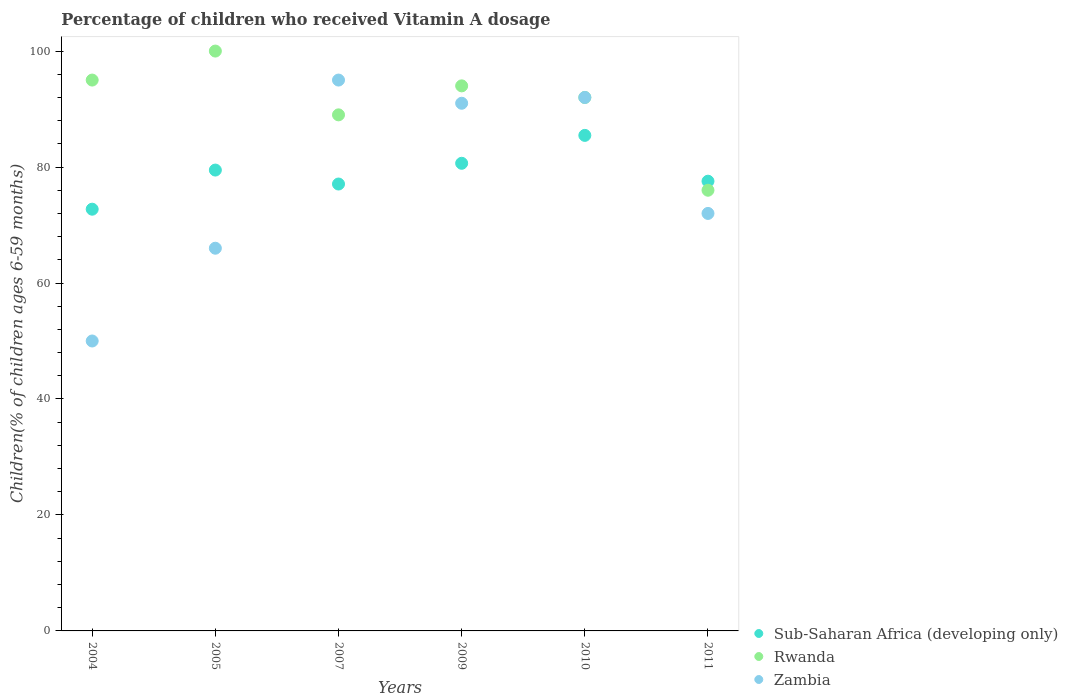Is the number of dotlines equal to the number of legend labels?
Provide a succinct answer. Yes. What is the percentage of children who received Vitamin A dosage in Sub-Saharan Africa (developing only) in 2005?
Your response must be concise. 79.48. Across all years, what is the maximum percentage of children who received Vitamin A dosage in Rwanda?
Keep it short and to the point. 100. What is the total percentage of children who received Vitamin A dosage in Sub-Saharan Africa (developing only) in the graph?
Your answer should be very brief. 472.95. What is the difference between the percentage of children who received Vitamin A dosage in Rwanda in 2009 and that in 2010?
Offer a terse response. 2. What is the difference between the percentage of children who received Vitamin A dosage in Zambia in 2011 and the percentage of children who received Vitamin A dosage in Rwanda in 2007?
Make the answer very short. -17. What is the average percentage of children who received Vitamin A dosage in Rwanda per year?
Your answer should be compact. 91. In the year 2011, what is the difference between the percentage of children who received Vitamin A dosage in Zambia and percentage of children who received Vitamin A dosage in Sub-Saharan Africa (developing only)?
Your answer should be compact. -5.56. In how many years, is the percentage of children who received Vitamin A dosage in Rwanda greater than 96 %?
Provide a short and direct response. 1. What is the ratio of the percentage of children who received Vitamin A dosage in Sub-Saharan Africa (developing only) in 2009 to that in 2011?
Ensure brevity in your answer.  1.04. Is the difference between the percentage of children who received Vitamin A dosage in Zambia in 2010 and 2011 greater than the difference between the percentage of children who received Vitamin A dosage in Sub-Saharan Africa (developing only) in 2010 and 2011?
Your response must be concise. Yes. What is the difference between the highest and the second highest percentage of children who received Vitamin A dosage in Sub-Saharan Africa (developing only)?
Keep it short and to the point. 4.81. What is the difference between the highest and the lowest percentage of children who received Vitamin A dosage in Zambia?
Offer a very short reply. 45. Is it the case that in every year, the sum of the percentage of children who received Vitamin A dosage in Zambia and percentage of children who received Vitamin A dosage in Rwanda  is greater than the percentage of children who received Vitamin A dosage in Sub-Saharan Africa (developing only)?
Offer a terse response. Yes. How many dotlines are there?
Make the answer very short. 3. What is the difference between two consecutive major ticks on the Y-axis?
Provide a succinct answer. 20. Does the graph contain any zero values?
Make the answer very short. No. Does the graph contain grids?
Your answer should be very brief. No. Where does the legend appear in the graph?
Your answer should be compact. Bottom right. What is the title of the graph?
Give a very brief answer. Percentage of children who received Vitamin A dosage. Does "Bangladesh" appear as one of the legend labels in the graph?
Make the answer very short. No. What is the label or title of the X-axis?
Your answer should be very brief. Years. What is the label or title of the Y-axis?
Offer a very short reply. Children(% of children ages 6-59 months). What is the Children(% of children ages 6-59 months) in Sub-Saharan Africa (developing only) in 2004?
Provide a short and direct response. 72.73. What is the Children(% of children ages 6-59 months) in Sub-Saharan Africa (developing only) in 2005?
Provide a succinct answer. 79.48. What is the Children(% of children ages 6-59 months) of Rwanda in 2005?
Your answer should be very brief. 100. What is the Children(% of children ages 6-59 months) of Zambia in 2005?
Provide a succinct answer. 66. What is the Children(% of children ages 6-59 months) of Sub-Saharan Africa (developing only) in 2007?
Your answer should be very brief. 77.07. What is the Children(% of children ages 6-59 months) in Rwanda in 2007?
Provide a short and direct response. 89. What is the Children(% of children ages 6-59 months) in Zambia in 2007?
Provide a short and direct response. 95. What is the Children(% of children ages 6-59 months) in Sub-Saharan Africa (developing only) in 2009?
Keep it short and to the point. 80.65. What is the Children(% of children ages 6-59 months) in Rwanda in 2009?
Your answer should be compact. 94. What is the Children(% of children ages 6-59 months) of Zambia in 2009?
Your answer should be very brief. 91. What is the Children(% of children ages 6-59 months) in Sub-Saharan Africa (developing only) in 2010?
Offer a very short reply. 85.46. What is the Children(% of children ages 6-59 months) in Rwanda in 2010?
Make the answer very short. 92. What is the Children(% of children ages 6-59 months) in Zambia in 2010?
Offer a terse response. 92. What is the Children(% of children ages 6-59 months) of Sub-Saharan Africa (developing only) in 2011?
Keep it short and to the point. 77.56. What is the Children(% of children ages 6-59 months) of Zambia in 2011?
Ensure brevity in your answer.  72. Across all years, what is the maximum Children(% of children ages 6-59 months) of Sub-Saharan Africa (developing only)?
Give a very brief answer. 85.46. Across all years, what is the maximum Children(% of children ages 6-59 months) of Zambia?
Offer a terse response. 95. Across all years, what is the minimum Children(% of children ages 6-59 months) in Sub-Saharan Africa (developing only)?
Give a very brief answer. 72.73. Across all years, what is the minimum Children(% of children ages 6-59 months) in Rwanda?
Your response must be concise. 76. Across all years, what is the minimum Children(% of children ages 6-59 months) of Zambia?
Keep it short and to the point. 50. What is the total Children(% of children ages 6-59 months) of Sub-Saharan Africa (developing only) in the graph?
Offer a terse response. 472.95. What is the total Children(% of children ages 6-59 months) in Rwanda in the graph?
Provide a succinct answer. 546. What is the total Children(% of children ages 6-59 months) of Zambia in the graph?
Your answer should be very brief. 466. What is the difference between the Children(% of children ages 6-59 months) in Sub-Saharan Africa (developing only) in 2004 and that in 2005?
Keep it short and to the point. -6.75. What is the difference between the Children(% of children ages 6-59 months) in Zambia in 2004 and that in 2005?
Ensure brevity in your answer.  -16. What is the difference between the Children(% of children ages 6-59 months) of Sub-Saharan Africa (developing only) in 2004 and that in 2007?
Your answer should be very brief. -4.34. What is the difference between the Children(% of children ages 6-59 months) of Zambia in 2004 and that in 2007?
Your answer should be very brief. -45. What is the difference between the Children(% of children ages 6-59 months) of Sub-Saharan Africa (developing only) in 2004 and that in 2009?
Offer a terse response. -7.92. What is the difference between the Children(% of children ages 6-59 months) of Rwanda in 2004 and that in 2009?
Provide a succinct answer. 1. What is the difference between the Children(% of children ages 6-59 months) of Zambia in 2004 and that in 2009?
Provide a succinct answer. -41. What is the difference between the Children(% of children ages 6-59 months) in Sub-Saharan Africa (developing only) in 2004 and that in 2010?
Your answer should be very brief. -12.73. What is the difference between the Children(% of children ages 6-59 months) of Rwanda in 2004 and that in 2010?
Keep it short and to the point. 3. What is the difference between the Children(% of children ages 6-59 months) of Zambia in 2004 and that in 2010?
Provide a succinct answer. -42. What is the difference between the Children(% of children ages 6-59 months) of Sub-Saharan Africa (developing only) in 2004 and that in 2011?
Offer a terse response. -4.83. What is the difference between the Children(% of children ages 6-59 months) of Rwanda in 2004 and that in 2011?
Your response must be concise. 19. What is the difference between the Children(% of children ages 6-59 months) in Zambia in 2004 and that in 2011?
Offer a very short reply. -22. What is the difference between the Children(% of children ages 6-59 months) of Sub-Saharan Africa (developing only) in 2005 and that in 2007?
Your answer should be compact. 2.41. What is the difference between the Children(% of children ages 6-59 months) of Sub-Saharan Africa (developing only) in 2005 and that in 2009?
Your answer should be very brief. -1.17. What is the difference between the Children(% of children ages 6-59 months) in Zambia in 2005 and that in 2009?
Provide a succinct answer. -25. What is the difference between the Children(% of children ages 6-59 months) of Sub-Saharan Africa (developing only) in 2005 and that in 2010?
Your response must be concise. -5.98. What is the difference between the Children(% of children ages 6-59 months) of Rwanda in 2005 and that in 2010?
Ensure brevity in your answer.  8. What is the difference between the Children(% of children ages 6-59 months) of Zambia in 2005 and that in 2010?
Your response must be concise. -26. What is the difference between the Children(% of children ages 6-59 months) in Sub-Saharan Africa (developing only) in 2005 and that in 2011?
Ensure brevity in your answer.  1.92. What is the difference between the Children(% of children ages 6-59 months) in Rwanda in 2005 and that in 2011?
Offer a terse response. 24. What is the difference between the Children(% of children ages 6-59 months) of Sub-Saharan Africa (developing only) in 2007 and that in 2009?
Provide a short and direct response. -3.58. What is the difference between the Children(% of children ages 6-59 months) in Rwanda in 2007 and that in 2009?
Provide a short and direct response. -5. What is the difference between the Children(% of children ages 6-59 months) in Zambia in 2007 and that in 2009?
Ensure brevity in your answer.  4. What is the difference between the Children(% of children ages 6-59 months) in Sub-Saharan Africa (developing only) in 2007 and that in 2010?
Your response must be concise. -8.39. What is the difference between the Children(% of children ages 6-59 months) in Rwanda in 2007 and that in 2010?
Your answer should be very brief. -3. What is the difference between the Children(% of children ages 6-59 months) of Sub-Saharan Africa (developing only) in 2007 and that in 2011?
Give a very brief answer. -0.49. What is the difference between the Children(% of children ages 6-59 months) in Zambia in 2007 and that in 2011?
Your response must be concise. 23. What is the difference between the Children(% of children ages 6-59 months) of Sub-Saharan Africa (developing only) in 2009 and that in 2010?
Provide a succinct answer. -4.81. What is the difference between the Children(% of children ages 6-59 months) of Sub-Saharan Africa (developing only) in 2009 and that in 2011?
Ensure brevity in your answer.  3.09. What is the difference between the Children(% of children ages 6-59 months) in Rwanda in 2009 and that in 2011?
Keep it short and to the point. 18. What is the difference between the Children(% of children ages 6-59 months) in Zambia in 2009 and that in 2011?
Your response must be concise. 19. What is the difference between the Children(% of children ages 6-59 months) in Sub-Saharan Africa (developing only) in 2010 and that in 2011?
Ensure brevity in your answer.  7.9. What is the difference between the Children(% of children ages 6-59 months) of Rwanda in 2010 and that in 2011?
Offer a very short reply. 16. What is the difference between the Children(% of children ages 6-59 months) in Sub-Saharan Africa (developing only) in 2004 and the Children(% of children ages 6-59 months) in Rwanda in 2005?
Keep it short and to the point. -27.27. What is the difference between the Children(% of children ages 6-59 months) in Sub-Saharan Africa (developing only) in 2004 and the Children(% of children ages 6-59 months) in Zambia in 2005?
Keep it short and to the point. 6.73. What is the difference between the Children(% of children ages 6-59 months) in Rwanda in 2004 and the Children(% of children ages 6-59 months) in Zambia in 2005?
Make the answer very short. 29. What is the difference between the Children(% of children ages 6-59 months) in Sub-Saharan Africa (developing only) in 2004 and the Children(% of children ages 6-59 months) in Rwanda in 2007?
Your answer should be compact. -16.27. What is the difference between the Children(% of children ages 6-59 months) of Sub-Saharan Africa (developing only) in 2004 and the Children(% of children ages 6-59 months) of Zambia in 2007?
Your response must be concise. -22.27. What is the difference between the Children(% of children ages 6-59 months) in Sub-Saharan Africa (developing only) in 2004 and the Children(% of children ages 6-59 months) in Rwanda in 2009?
Ensure brevity in your answer.  -21.27. What is the difference between the Children(% of children ages 6-59 months) in Sub-Saharan Africa (developing only) in 2004 and the Children(% of children ages 6-59 months) in Zambia in 2009?
Provide a succinct answer. -18.27. What is the difference between the Children(% of children ages 6-59 months) in Rwanda in 2004 and the Children(% of children ages 6-59 months) in Zambia in 2009?
Make the answer very short. 4. What is the difference between the Children(% of children ages 6-59 months) in Sub-Saharan Africa (developing only) in 2004 and the Children(% of children ages 6-59 months) in Rwanda in 2010?
Offer a very short reply. -19.27. What is the difference between the Children(% of children ages 6-59 months) in Sub-Saharan Africa (developing only) in 2004 and the Children(% of children ages 6-59 months) in Zambia in 2010?
Your answer should be compact. -19.27. What is the difference between the Children(% of children ages 6-59 months) of Rwanda in 2004 and the Children(% of children ages 6-59 months) of Zambia in 2010?
Your response must be concise. 3. What is the difference between the Children(% of children ages 6-59 months) of Sub-Saharan Africa (developing only) in 2004 and the Children(% of children ages 6-59 months) of Rwanda in 2011?
Offer a very short reply. -3.27. What is the difference between the Children(% of children ages 6-59 months) in Sub-Saharan Africa (developing only) in 2004 and the Children(% of children ages 6-59 months) in Zambia in 2011?
Give a very brief answer. 0.73. What is the difference between the Children(% of children ages 6-59 months) in Rwanda in 2004 and the Children(% of children ages 6-59 months) in Zambia in 2011?
Give a very brief answer. 23. What is the difference between the Children(% of children ages 6-59 months) in Sub-Saharan Africa (developing only) in 2005 and the Children(% of children ages 6-59 months) in Rwanda in 2007?
Provide a succinct answer. -9.52. What is the difference between the Children(% of children ages 6-59 months) of Sub-Saharan Africa (developing only) in 2005 and the Children(% of children ages 6-59 months) of Zambia in 2007?
Your response must be concise. -15.52. What is the difference between the Children(% of children ages 6-59 months) in Sub-Saharan Africa (developing only) in 2005 and the Children(% of children ages 6-59 months) in Rwanda in 2009?
Make the answer very short. -14.52. What is the difference between the Children(% of children ages 6-59 months) of Sub-Saharan Africa (developing only) in 2005 and the Children(% of children ages 6-59 months) of Zambia in 2009?
Offer a very short reply. -11.52. What is the difference between the Children(% of children ages 6-59 months) in Rwanda in 2005 and the Children(% of children ages 6-59 months) in Zambia in 2009?
Ensure brevity in your answer.  9. What is the difference between the Children(% of children ages 6-59 months) of Sub-Saharan Africa (developing only) in 2005 and the Children(% of children ages 6-59 months) of Rwanda in 2010?
Give a very brief answer. -12.52. What is the difference between the Children(% of children ages 6-59 months) in Sub-Saharan Africa (developing only) in 2005 and the Children(% of children ages 6-59 months) in Zambia in 2010?
Give a very brief answer. -12.52. What is the difference between the Children(% of children ages 6-59 months) of Sub-Saharan Africa (developing only) in 2005 and the Children(% of children ages 6-59 months) of Rwanda in 2011?
Offer a terse response. 3.48. What is the difference between the Children(% of children ages 6-59 months) of Sub-Saharan Africa (developing only) in 2005 and the Children(% of children ages 6-59 months) of Zambia in 2011?
Keep it short and to the point. 7.48. What is the difference between the Children(% of children ages 6-59 months) in Rwanda in 2005 and the Children(% of children ages 6-59 months) in Zambia in 2011?
Your answer should be very brief. 28. What is the difference between the Children(% of children ages 6-59 months) of Sub-Saharan Africa (developing only) in 2007 and the Children(% of children ages 6-59 months) of Rwanda in 2009?
Offer a terse response. -16.93. What is the difference between the Children(% of children ages 6-59 months) in Sub-Saharan Africa (developing only) in 2007 and the Children(% of children ages 6-59 months) in Zambia in 2009?
Offer a terse response. -13.93. What is the difference between the Children(% of children ages 6-59 months) of Sub-Saharan Africa (developing only) in 2007 and the Children(% of children ages 6-59 months) of Rwanda in 2010?
Provide a short and direct response. -14.93. What is the difference between the Children(% of children ages 6-59 months) in Sub-Saharan Africa (developing only) in 2007 and the Children(% of children ages 6-59 months) in Zambia in 2010?
Your answer should be very brief. -14.93. What is the difference between the Children(% of children ages 6-59 months) of Sub-Saharan Africa (developing only) in 2007 and the Children(% of children ages 6-59 months) of Rwanda in 2011?
Provide a short and direct response. 1.07. What is the difference between the Children(% of children ages 6-59 months) of Sub-Saharan Africa (developing only) in 2007 and the Children(% of children ages 6-59 months) of Zambia in 2011?
Provide a succinct answer. 5.07. What is the difference between the Children(% of children ages 6-59 months) in Sub-Saharan Africa (developing only) in 2009 and the Children(% of children ages 6-59 months) in Rwanda in 2010?
Give a very brief answer. -11.35. What is the difference between the Children(% of children ages 6-59 months) of Sub-Saharan Africa (developing only) in 2009 and the Children(% of children ages 6-59 months) of Zambia in 2010?
Your response must be concise. -11.35. What is the difference between the Children(% of children ages 6-59 months) in Rwanda in 2009 and the Children(% of children ages 6-59 months) in Zambia in 2010?
Ensure brevity in your answer.  2. What is the difference between the Children(% of children ages 6-59 months) in Sub-Saharan Africa (developing only) in 2009 and the Children(% of children ages 6-59 months) in Rwanda in 2011?
Give a very brief answer. 4.65. What is the difference between the Children(% of children ages 6-59 months) in Sub-Saharan Africa (developing only) in 2009 and the Children(% of children ages 6-59 months) in Zambia in 2011?
Offer a very short reply. 8.65. What is the difference between the Children(% of children ages 6-59 months) of Sub-Saharan Africa (developing only) in 2010 and the Children(% of children ages 6-59 months) of Rwanda in 2011?
Provide a succinct answer. 9.46. What is the difference between the Children(% of children ages 6-59 months) in Sub-Saharan Africa (developing only) in 2010 and the Children(% of children ages 6-59 months) in Zambia in 2011?
Provide a short and direct response. 13.46. What is the average Children(% of children ages 6-59 months) of Sub-Saharan Africa (developing only) per year?
Keep it short and to the point. 78.82. What is the average Children(% of children ages 6-59 months) of Rwanda per year?
Your answer should be very brief. 91. What is the average Children(% of children ages 6-59 months) of Zambia per year?
Provide a short and direct response. 77.67. In the year 2004, what is the difference between the Children(% of children ages 6-59 months) in Sub-Saharan Africa (developing only) and Children(% of children ages 6-59 months) in Rwanda?
Your answer should be very brief. -22.27. In the year 2004, what is the difference between the Children(% of children ages 6-59 months) of Sub-Saharan Africa (developing only) and Children(% of children ages 6-59 months) of Zambia?
Your answer should be very brief. 22.73. In the year 2004, what is the difference between the Children(% of children ages 6-59 months) of Rwanda and Children(% of children ages 6-59 months) of Zambia?
Offer a terse response. 45. In the year 2005, what is the difference between the Children(% of children ages 6-59 months) in Sub-Saharan Africa (developing only) and Children(% of children ages 6-59 months) in Rwanda?
Your answer should be compact. -20.52. In the year 2005, what is the difference between the Children(% of children ages 6-59 months) of Sub-Saharan Africa (developing only) and Children(% of children ages 6-59 months) of Zambia?
Provide a succinct answer. 13.48. In the year 2005, what is the difference between the Children(% of children ages 6-59 months) in Rwanda and Children(% of children ages 6-59 months) in Zambia?
Provide a succinct answer. 34. In the year 2007, what is the difference between the Children(% of children ages 6-59 months) of Sub-Saharan Africa (developing only) and Children(% of children ages 6-59 months) of Rwanda?
Your answer should be compact. -11.93. In the year 2007, what is the difference between the Children(% of children ages 6-59 months) of Sub-Saharan Africa (developing only) and Children(% of children ages 6-59 months) of Zambia?
Make the answer very short. -17.93. In the year 2007, what is the difference between the Children(% of children ages 6-59 months) in Rwanda and Children(% of children ages 6-59 months) in Zambia?
Offer a terse response. -6. In the year 2009, what is the difference between the Children(% of children ages 6-59 months) in Sub-Saharan Africa (developing only) and Children(% of children ages 6-59 months) in Rwanda?
Offer a terse response. -13.35. In the year 2009, what is the difference between the Children(% of children ages 6-59 months) of Sub-Saharan Africa (developing only) and Children(% of children ages 6-59 months) of Zambia?
Provide a short and direct response. -10.35. In the year 2010, what is the difference between the Children(% of children ages 6-59 months) in Sub-Saharan Africa (developing only) and Children(% of children ages 6-59 months) in Rwanda?
Offer a very short reply. -6.54. In the year 2010, what is the difference between the Children(% of children ages 6-59 months) of Sub-Saharan Africa (developing only) and Children(% of children ages 6-59 months) of Zambia?
Keep it short and to the point. -6.54. In the year 2011, what is the difference between the Children(% of children ages 6-59 months) of Sub-Saharan Africa (developing only) and Children(% of children ages 6-59 months) of Rwanda?
Ensure brevity in your answer.  1.56. In the year 2011, what is the difference between the Children(% of children ages 6-59 months) in Sub-Saharan Africa (developing only) and Children(% of children ages 6-59 months) in Zambia?
Give a very brief answer. 5.56. In the year 2011, what is the difference between the Children(% of children ages 6-59 months) in Rwanda and Children(% of children ages 6-59 months) in Zambia?
Make the answer very short. 4. What is the ratio of the Children(% of children ages 6-59 months) of Sub-Saharan Africa (developing only) in 2004 to that in 2005?
Offer a terse response. 0.92. What is the ratio of the Children(% of children ages 6-59 months) in Zambia in 2004 to that in 2005?
Offer a very short reply. 0.76. What is the ratio of the Children(% of children ages 6-59 months) in Sub-Saharan Africa (developing only) in 2004 to that in 2007?
Ensure brevity in your answer.  0.94. What is the ratio of the Children(% of children ages 6-59 months) in Rwanda in 2004 to that in 2007?
Keep it short and to the point. 1.07. What is the ratio of the Children(% of children ages 6-59 months) of Zambia in 2004 to that in 2007?
Provide a short and direct response. 0.53. What is the ratio of the Children(% of children ages 6-59 months) in Sub-Saharan Africa (developing only) in 2004 to that in 2009?
Provide a succinct answer. 0.9. What is the ratio of the Children(% of children ages 6-59 months) of Rwanda in 2004 to that in 2009?
Provide a short and direct response. 1.01. What is the ratio of the Children(% of children ages 6-59 months) of Zambia in 2004 to that in 2009?
Offer a very short reply. 0.55. What is the ratio of the Children(% of children ages 6-59 months) in Sub-Saharan Africa (developing only) in 2004 to that in 2010?
Ensure brevity in your answer.  0.85. What is the ratio of the Children(% of children ages 6-59 months) of Rwanda in 2004 to that in 2010?
Make the answer very short. 1.03. What is the ratio of the Children(% of children ages 6-59 months) of Zambia in 2004 to that in 2010?
Provide a short and direct response. 0.54. What is the ratio of the Children(% of children ages 6-59 months) of Sub-Saharan Africa (developing only) in 2004 to that in 2011?
Keep it short and to the point. 0.94. What is the ratio of the Children(% of children ages 6-59 months) of Zambia in 2004 to that in 2011?
Make the answer very short. 0.69. What is the ratio of the Children(% of children ages 6-59 months) of Sub-Saharan Africa (developing only) in 2005 to that in 2007?
Your answer should be compact. 1.03. What is the ratio of the Children(% of children ages 6-59 months) in Rwanda in 2005 to that in 2007?
Your response must be concise. 1.12. What is the ratio of the Children(% of children ages 6-59 months) of Zambia in 2005 to that in 2007?
Give a very brief answer. 0.69. What is the ratio of the Children(% of children ages 6-59 months) in Sub-Saharan Africa (developing only) in 2005 to that in 2009?
Your answer should be compact. 0.99. What is the ratio of the Children(% of children ages 6-59 months) of Rwanda in 2005 to that in 2009?
Offer a very short reply. 1.06. What is the ratio of the Children(% of children ages 6-59 months) of Zambia in 2005 to that in 2009?
Provide a short and direct response. 0.73. What is the ratio of the Children(% of children ages 6-59 months) of Sub-Saharan Africa (developing only) in 2005 to that in 2010?
Your response must be concise. 0.93. What is the ratio of the Children(% of children ages 6-59 months) in Rwanda in 2005 to that in 2010?
Offer a terse response. 1.09. What is the ratio of the Children(% of children ages 6-59 months) of Zambia in 2005 to that in 2010?
Your answer should be very brief. 0.72. What is the ratio of the Children(% of children ages 6-59 months) in Sub-Saharan Africa (developing only) in 2005 to that in 2011?
Offer a terse response. 1.02. What is the ratio of the Children(% of children ages 6-59 months) of Rwanda in 2005 to that in 2011?
Your answer should be compact. 1.32. What is the ratio of the Children(% of children ages 6-59 months) in Zambia in 2005 to that in 2011?
Make the answer very short. 0.92. What is the ratio of the Children(% of children ages 6-59 months) of Sub-Saharan Africa (developing only) in 2007 to that in 2009?
Offer a very short reply. 0.96. What is the ratio of the Children(% of children ages 6-59 months) of Rwanda in 2007 to that in 2009?
Provide a short and direct response. 0.95. What is the ratio of the Children(% of children ages 6-59 months) in Zambia in 2007 to that in 2009?
Give a very brief answer. 1.04. What is the ratio of the Children(% of children ages 6-59 months) of Sub-Saharan Africa (developing only) in 2007 to that in 2010?
Keep it short and to the point. 0.9. What is the ratio of the Children(% of children ages 6-59 months) of Rwanda in 2007 to that in 2010?
Give a very brief answer. 0.97. What is the ratio of the Children(% of children ages 6-59 months) in Zambia in 2007 to that in 2010?
Make the answer very short. 1.03. What is the ratio of the Children(% of children ages 6-59 months) of Sub-Saharan Africa (developing only) in 2007 to that in 2011?
Give a very brief answer. 0.99. What is the ratio of the Children(% of children ages 6-59 months) in Rwanda in 2007 to that in 2011?
Offer a terse response. 1.17. What is the ratio of the Children(% of children ages 6-59 months) in Zambia in 2007 to that in 2011?
Offer a very short reply. 1.32. What is the ratio of the Children(% of children ages 6-59 months) of Sub-Saharan Africa (developing only) in 2009 to that in 2010?
Keep it short and to the point. 0.94. What is the ratio of the Children(% of children ages 6-59 months) of Rwanda in 2009 to that in 2010?
Keep it short and to the point. 1.02. What is the ratio of the Children(% of children ages 6-59 months) in Sub-Saharan Africa (developing only) in 2009 to that in 2011?
Provide a short and direct response. 1.04. What is the ratio of the Children(% of children ages 6-59 months) of Rwanda in 2009 to that in 2011?
Offer a terse response. 1.24. What is the ratio of the Children(% of children ages 6-59 months) in Zambia in 2009 to that in 2011?
Give a very brief answer. 1.26. What is the ratio of the Children(% of children ages 6-59 months) of Sub-Saharan Africa (developing only) in 2010 to that in 2011?
Make the answer very short. 1.1. What is the ratio of the Children(% of children ages 6-59 months) of Rwanda in 2010 to that in 2011?
Keep it short and to the point. 1.21. What is the ratio of the Children(% of children ages 6-59 months) in Zambia in 2010 to that in 2011?
Your answer should be compact. 1.28. What is the difference between the highest and the second highest Children(% of children ages 6-59 months) in Sub-Saharan Africa (developing only)?
Your answer should be very brief. 4.81. What is the difference between the highest and the second highest Children(% of children ages 6-59 months) in Rwanda?
Ensure brevity in your answer.  5. What is the difference between the highest and the second highest Children(% of children ages 6-59 months) of Zambia?
Your answer should be compact. 3. What is the difference between the highest and the lowest Children(% of children ages 6-59 months) in Sub-Saharan Africa (developing only)?
Provide a succinct answer. 12.73. What is the difference between the highest and the lowest Children(% of children ages 6-59 months) in Rwanda?
Your answer should be very brief. 24. What is the difference between the highest and the lowest Children(% of children ages 6-59 months) in Zambia?
Your answer should be compact. 45. 